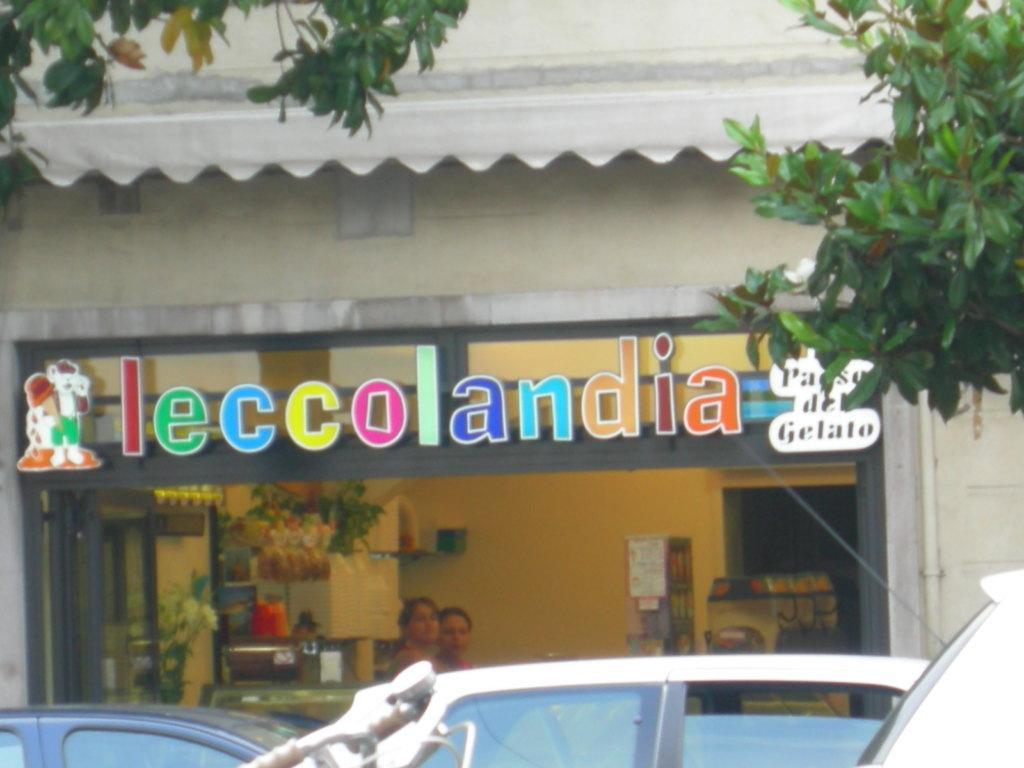In one or two sentences, can you explain what this image depicts? In this image, there is an outside view. There are cars in front of the building. There are branches in the top right and in the top left of the image. 